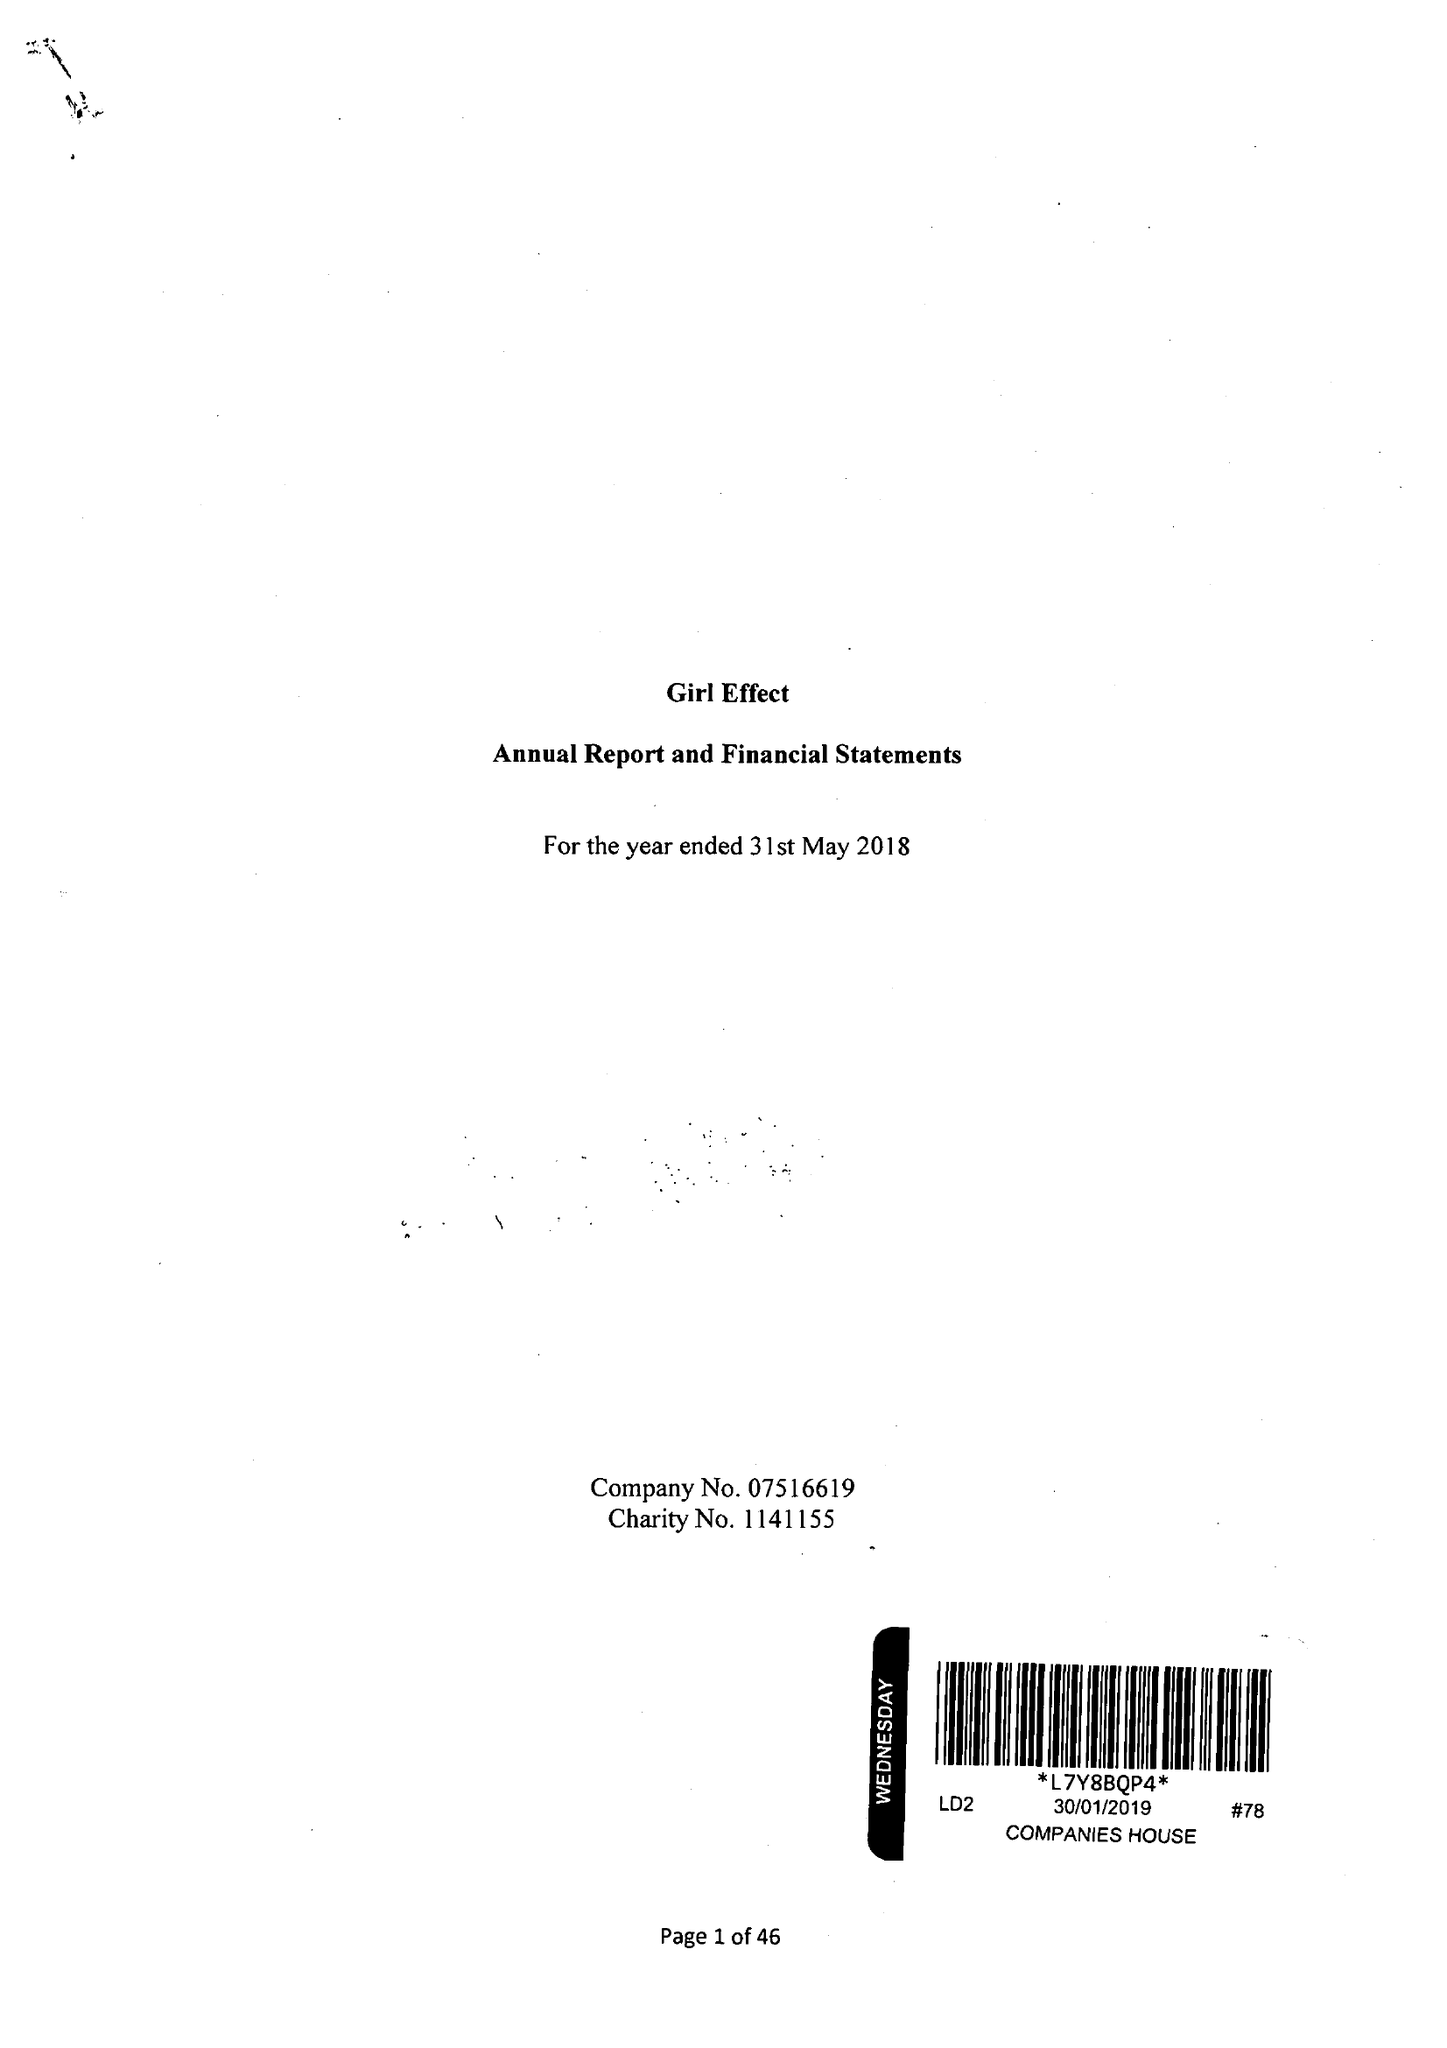What is the value for the address__post_town?
Answer the question using a single word or phrase. LONDON 